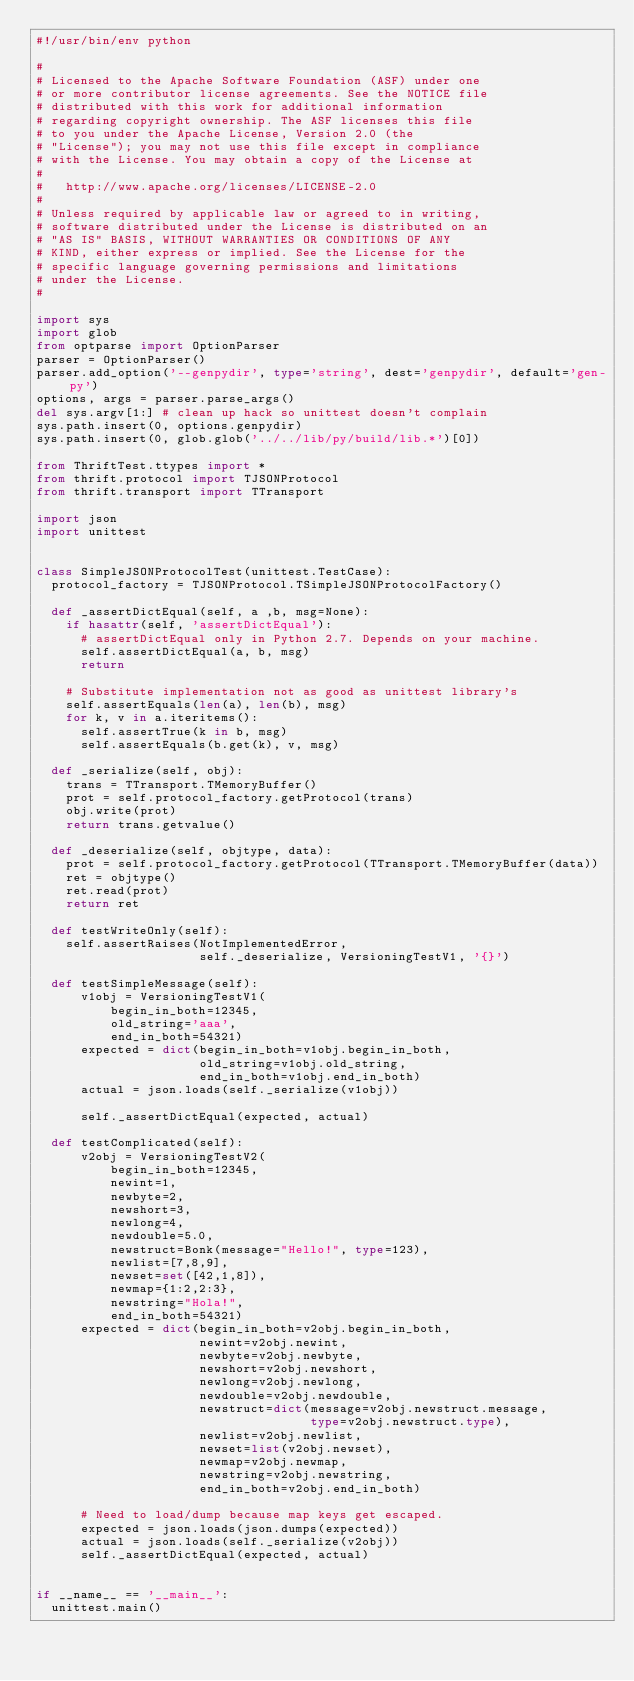Convert code to text. <code><loc_0><loc_0><loc_500><loc_500><_Python_>#!/usr/bin/env python

#
# Licensed to the Apache Software Foundation (ASF) under one
# or more contributor license agreements. See the NOTICE file
# distributed with this work for additional information
# regarding copyright ownership. The ASF licenses this file
# to you under the Apache License, Version 2.0 (the
# "License"); you may not use this file except in compliance
# with the License. You may obtain a copy of the License at
#
#   http://www.apache.org/licenses/LICENSE-2.0
#
# Unless required by applicable law or agreed to in writing,
# software distributed under the License is distributed on an
# "AS IS" BASIS, WITHOUT WARRANTIES OR CONDITIONS OF ANY
# KIND, either express or implied. See the License for the
# specific language governing permissions and limitations
# under the License.
#

import sys
import glob
from optparse import OptionParser
parser = OptionParser()
parser.add_option('--genpydir', type='string', dest='genpydir', default='gen-py')
options, args = parser.parse_args()
del sys.argv[1:] # clean up hack so unittest doesn't complain
sys.path.insert(0, options.genpydir)
sys.path.insert(0, glob.glob('../../lib/py/build/lib.*')[0])

from ThriftTest.ttypes import *
from thrift.protocol import TJSONProtocol
from thrift.transport import TTransport

import json
import unittest


class SimpleJSONProtocolTest(unittest.TestCase):
  protocol_factory = TJSONProtocol.TSimpleJSONProtocolFactory()

  def _assertDictEqual(self, a ,b, msg=None):
    if hasattr(self, 'assertDictEqual'):
      # assertDictEqual only in Python 2.7. Depends on your machine.
      self.assertDictEqual(a, b, msg)
      return
    
    # Substitute implementation not as good as unittest library's
    self.assertEquals(len(a), len(b), msg)
    for k, v in a.iteritems():
      self.assertTrue(k in b, msg)
      self.assertEquals(b.get(k), v, msg)

  def _serialize(self, obj):
    trans = TTransport.TMemoryBuffer()
    prot = self.protocol_factory.getProtocol(trans)
    obj.write(prot)
    return trans.getvalue()

  def _deserialize(self, objtype, data):
    prot = self.protocol_factory.getProtocol(TTransport.TMemoryBuffer(data))
    ret = objtype()
    ret.read(prot)
    return ret

  def testWriteOnly(self):
    self.assertRaises(NotImplementedError,
                      self._deserialize, VersioningTestV1, '{}')

  def testSimpleMessage(self):
      v1obj = VersioningTestV1(
          begin_in_both=12345,
          old_string='aaa',
          end_in_both=54321)
      expected = dict(begin_in_both=v1obj.begin_in_both,
                      old_string=v1obj.old_string,
                      end_in_both=v1obj.end_in_both)
      actual = json.loads(self._serialize(v1obj))

      self._assertDictEqual(expected, actual)
     
  def testComplicated(self):
      v2obj = VersioningTestV2(
          begin_in_both=12345,
          newint=1,
          newbyte=2,
          newshort=3,
          newlong=4,
          newdouble=5.0,
          newstruct=Bonk(message="Hello!", type=123),
          newlist=[7,8,9],
          newset=set([42,1,8]),
          newmap={1:2,2:3},
          newstring="Hola!",
          end_in_both=54321)
      expected = dict(begin_in_both=v2obj.begin_in_both,
                      newint=v2obj.newint,
                      newbyte=v2obj.newbyte,
                      newshort=v2obj.newshort,
                      newlong=v2obj.newlong,
                      newdouble=v2obj.newdouble,
                      newstruct=dict(message=v2obj.newstruct.message,
                                     type=v2obj.newstruct.type),
                      newlist=v2obj.newlist,
                      newset=list(v2obj.newset),
                      newmap=v2obj.newmap,
                      newstring=v2obj.newstring,
                      end_in_both=v2obj.end_in_both)
      
      # Need to load/dump because map keys get escaped.
      expected = json.loads(json.dumps(expected))
      actual = json.loads(self._serialize(v2obj))
      self._assertDictEqual(expected, actual)


if __name__ == '__main__':
  unittest.main()

</code> 